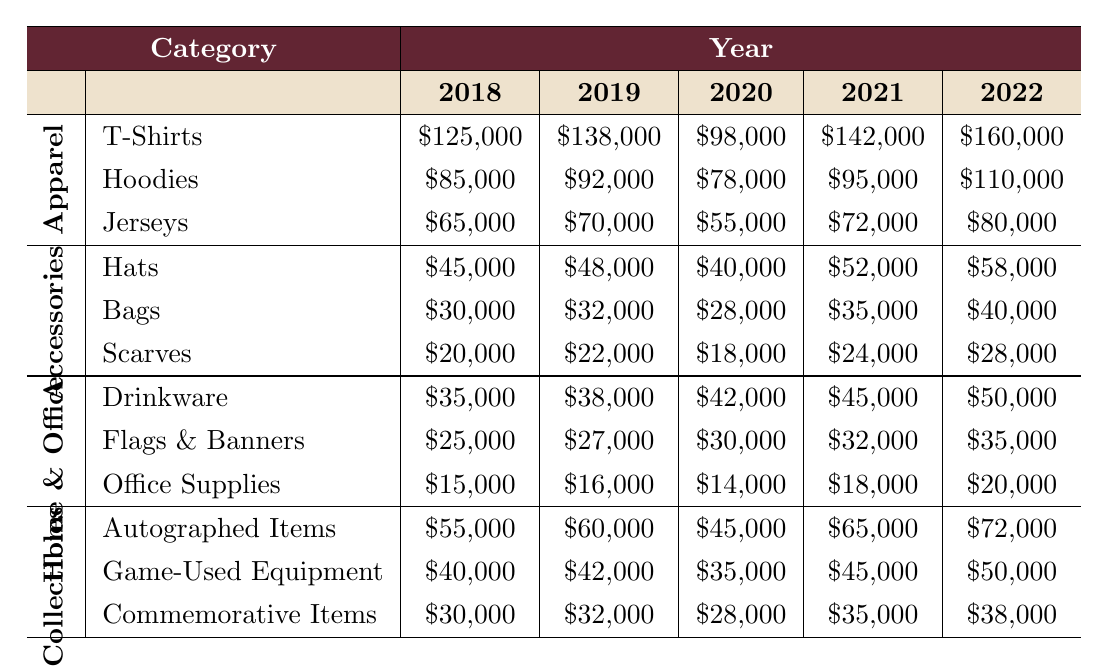What were the total sales for T-Shirts from 2018 to 2022? To find the total sales for T-Shirts, we need to sum the sales amounts for each year: 125,000 (2018) + 138,000 (2019) + 98,000 (2020) + 142,000 (2021) + 160,000 (2022) = 663,000.
Answer: 663,000 Which year had the highest sales for Hoodies? By reviewing the sales data for Hoodies from 2018 to 2022, the amounts are as follows: 85,000 (2018), 92,000 (2019), 78,000 (2020), 95,000 (2021), and 110,000 (2022). The highest sales occurred in 2022 with 110,000.
Answer: 2022 Did sales for Scarves increase every year from 2018 to 2022? The sales for Scarves are: 20,000 (2018), 22,000 (2019), 18,000 (2020), 24,000 (2021), and 28,000 (2022). There was a decrease from 2019 to 2020 (22,000 to 18,000), so the sales did not increase every year.
Answer: No What was the percentage increase in sales for Drinkware from 2018 to 2022? The sales for Drinkware in 2018 was 35,000, and in 2022 it was 50,000. The increase is 50,000 - 35,000 = 15,000. The percentage increase is (15,000 / 35,000) * 100 = 42.86%.
Answer: 42.86% What was the total sales for the Collectibles category in 2021? For the Collectibles category, the sales are: Autographed Items (65,000), Game-Used Equipment (45,000), and Commemorative Items (35,000) in 2021. The total sales for 2021 is 65,000 + 45,000 + 35,000 = 145,000.
Answer: 145,000 Which subcategory of Accessories had the lowest average sales over the five years? The sales for each subcategory are: Hats (average: 50,000), Bags (average: 33,000), and Scarves (average: 22,000). The average for Scarves is the lowest at 22,000.
Answer: Scarves What was the total sales growth from 2018 to 2022 for the Jerseys subcategory? The sales for Jerseys in 2018 was 65,000 and in 2022 it was 80,000. The growth is 80,000 - 65,000 = 15,000, or a growth of (15,000 / 65,000) * 100 ≈ 23.08%.
Answer: 23.08% In which category did sales decrease in 2020 compared to 2019? Reviewing the categories, Apparel's T-Shirts (138,000 to 98,000), Hoodies (92,000 to 78,000), and Jerseys (70,000 to 55,000) all decreased. Therefore, Apparel experienced decreases in all its subcategories.
Answer: Apparel What was the overall trend for sales in the Accessories category over the five years? The sales for Accessories over the years were: Hats (45,000, 48,000, 40,000, 52,000, 58,000), Bags (30,000, 32,000, 28,000, 35,000, 40,000), Scarves (20,000, 22,000, 18,000, 24,000, 28,000). All subcategories showed an increase in the latter years, signaling a general upward trend in Accessories.
Answer: Upward trend Which subcategory showed the most improvement in sales from 2021 to 2022? The sales for 2021 to 2022 are: T-Shirts (142,000 to 160,000, an increase of 18,000), Hoodies (95,000 to 110,000, an increase of 15,000), and Jerseys (72,000 to 80,000, an increase of 8,000). T-Shirts had the highest improvement of 18,000.
Answer: T-Shirts 